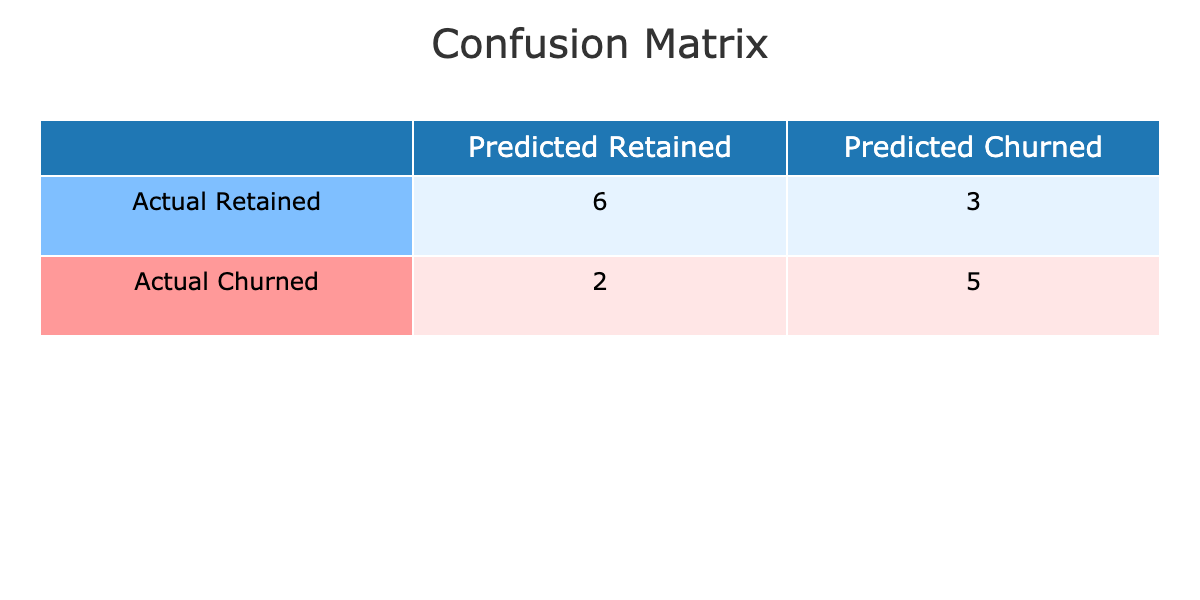What is the value of True Positives in the confusion matrix? True Positives correspond to the cases where the actual status is 'Retained' and the predicted status is also 'Retained'. Referring to the table, there are 6 occurrences of 'Actual Retained' and 'Predicted Retained'.
Answer: 6 What is the value of False Negatives in the confusion matrix? False Negatives occur when the actual status is 'Retained', but the predicted status is 'Churned'. From the table, there are 4 instances where 'Actual Retained' was predicted as 'Churned'.
Answer: 4 What is the total number of predicted 'Churned' cases? To find the total predicted 'Churned' cases, we sum the cells under the 'Predicted Churned' column, which represents both True Negatives and False Positives. The values are 4 (False Negatives) and 5 (True Negatives), leading to a total of 9.
Answer: 9 Are there more True Negatives than False Positives in the confusion matrix? True Negatives are the cases where 'Churned' is both actual and predicted, which equals 5. False Positives occur when 'Churned' is predicted while actual status is 'Retained', which equals 4. Since 5 > 4, the answer is yes.
Answer: Yes What is the overall accuracy based on the confusion matrix? Accuracy is defined as the sum of True Positives and True Negatives divided by the total number of cases. The total cases are 16, and the sum of True Positives (6) and True Negatives (5) is 11. Thus, the accuracy is 11/16 = 0.6875 or 68.75%.
Answer: 68.75% What is the number of customers who were incorrectly predicted as 'Retained'? Incorrect predictions of 'Retained' are denoted by False Negatives and False Positives combined. From the table, False Negatives are 4, and False Positives are 4, leading to an overall count of 4 + 4 = 8 customers incorrectly predicted as 'Retained'.
Answer: 8 What is the ratio of True Positives to False Negatives? The ratio of True Positives to False Negatives can be calculated by taking the number of True Positives (6) and dividing it by the number of False Negatives (4). This equates to 6/4 = 1.5.
Answer: 1.5 What percentage of actual 'Churned' cases were correctly predicted? The percentage of correctly predicted 'Churned' cases corresponds to True Negatives divided by the total actual 'Churned' cases. There were 5 True Negatives and a total of 6 actual 'Churned' cases (1 False Negative). Thus the percentage is (5/6) * 100 = 83.33%.
Answer: 83.33% How many instances indicate a confusion between actual 'Churned' customers? Instances indicating confusion can be determined by adding False Negatives and False Positives. In this scenario, there are 4 (False Negatives) for 'Churned' predicted as 'Retained' and 3 (False Positives) for 'Retained' predicted as 'Churned', leading to 4 + 3 = 7 instances.
Answer: 7 